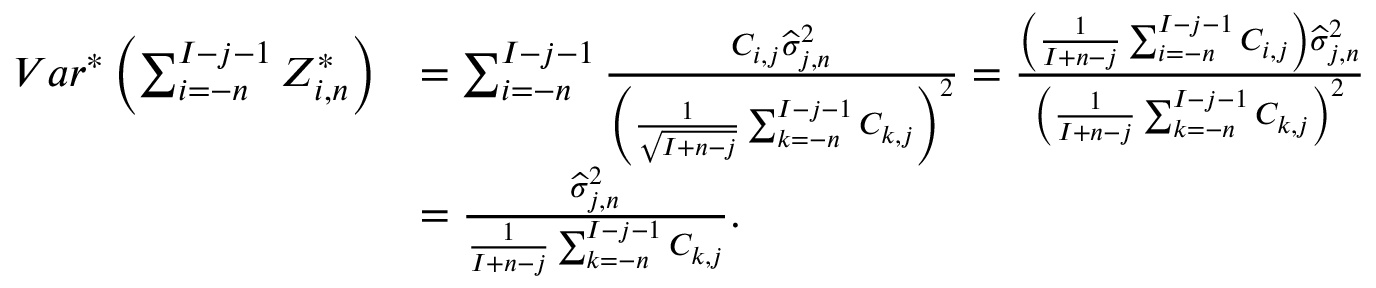<formula> <loc_0><loc_0><loc_500><loc_500>\begin{array} { r l } { V a r ^ { * } \left ( \sum _ { i = - n } ^ { I - j - 1 } Z _ { i , n } ^ { * } \right ) } & { = \sum _ { i = - n } ^ { I - j - 1 } \frac { C _ { i , j } \widehat { \sigma } _ { j , n } ^ { 2 } } { \left ( \frac { 1 } { \sqrt { I + n - j } } \sum _ { k = - n } ^ { I - j - 1 } C _ { k , j } \right ) ^ { 2 } } = \frac { \left ( \frac { 1 } { I + n - j } \sum _ { i = - n } ^ { I - j - 1 } C _ { i , j } \right ) \widehat { \sigma } _ { j , n } ^ { 2 } } { \left ( \frac { 1 } { I + n - j } \sum _ { k = - n } ^ { I - j - 1 } C _ { k , j } \right ) ^ { 2 } } } \\ & { = \frac { \widehat { \sigma } _ { j , n } ^ { 2 } } { \frac { 1 } { I + n - j } \sum _ { k = - n } ^ { I - j - 1 } C _ { k , j } } . } \end{array}</formula> 